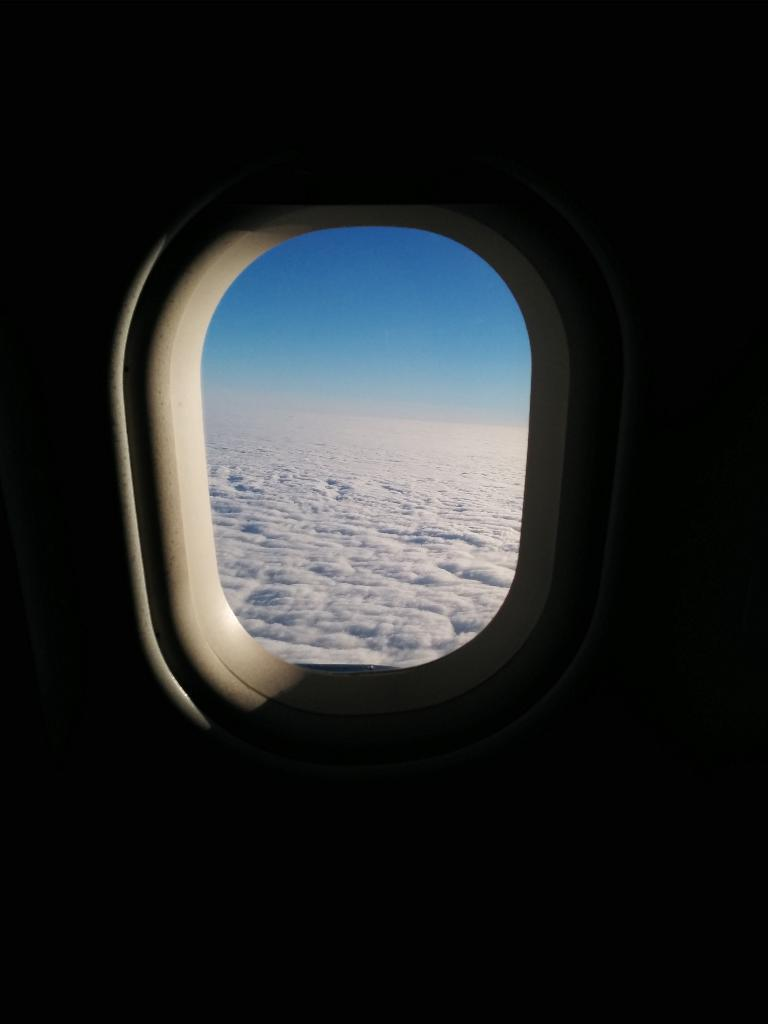What is present in the image that provides a view of the outside? There is a window in the image. What can be seen in the background of the image through the window? There are clouds in the background of the image. What else is visible in the background of the image? The sky is visible in the background of the image. How many buildings can be seen collapsing due to an earthquake in the image? There is no earthquake or collapsing buildings present in the image; it only features a window with clouds and sky in the background. 